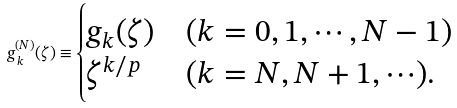Convert formula to latex. <formula><loc_0><loc_0><loc_500><loc_500>g ^ { ( N ) } _ { \, k } ( \zeta ) \equiv \begin{cases} g _ { k } ( \zeta ) & ( k = 0 , 1 , \cdots , N - 1 ) \\ \zeta ^ { k / p } & ( k = N , N + 1 , \cdots ) . \end{cases}</formula> 